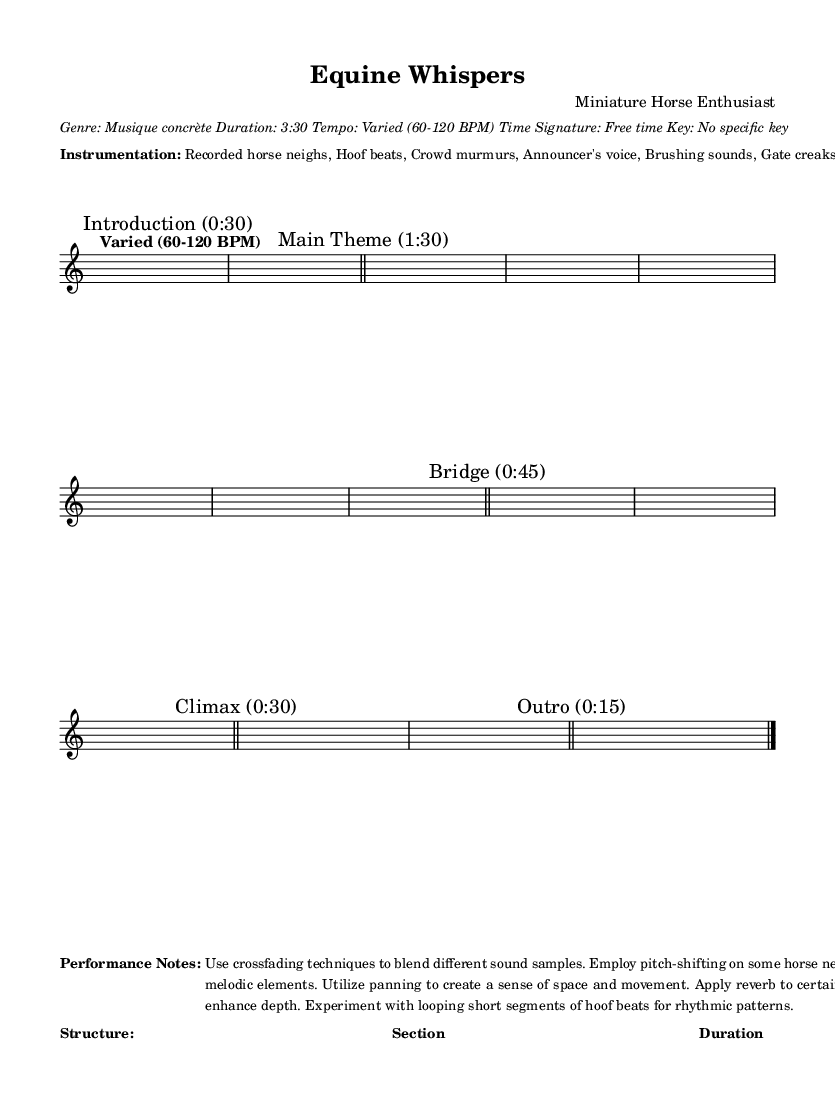What is the time signature of this piece? The time signature is indicated as free time, meaning there is no strict time signature applied throughout the piece. This allows for more flexibility in rhythm and pacing.
Answer: Free time What is the tempo of the music? The tempo is described as varied, ranging from 60 to 120 BPM, indicating changes in speed that create different emotional effects throughout the piece.
Answer: Varied (60-120 BPM) How long is the "Main Theme" section? The duration of the "Main Theme" section is specified as 1:30, which can be deduced from the overall structure presented in the sheet music.
Answer: 1:30 What elements are included in the instrumentation? The instrumentation includes specific sounds like recorded horse neighs, hoof beats, crowd murmurs, and other ambient noises that enhance the piece's unique character. By analyzing the performance notes, we see all listed elements are crucial to the composition.
Answer: Recorded horse neighs, Hoof beats, Crowd murmurs, Announcer's voice, Brushing sounds, Gate creaks What type of sound technique is suggested for the climax section? The climax section is described as having intense layering of sounds, indicating a crescendo in sound volume and complexity, which is typical for a climactic moment. This can be understood by reviewing the descriptions associated with the sections.
Answer: Intense layering What kind of atmosphere does the "Bridge" section aim to create? The "Bridge" section is noted for creating a calming atmosphere with soft brushing sounds and gentle neighs, suggesting a stark contrast to the more intense sections. This can be determined from the description provided for this specific part.
Answer: Calming atmosphere 